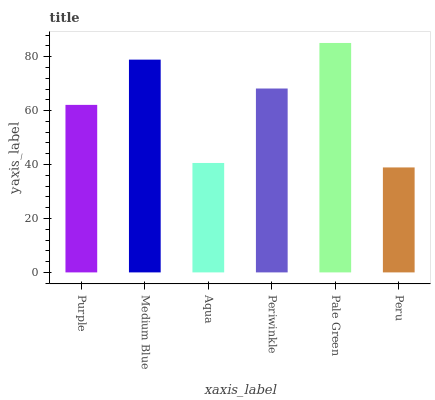Is Peru the minimum?
Answer yes or no. Yes. Is Pale Green the maximum?
Answer yes or no. Yes. Is Medium Blue the minimum?
Answer yes or no. No. Is Medium Blue the maximum?
Answer yes or no. No. Is Medium Blue greater than Purple?
Answer yes or no. Yes. Is Purple less than Medium Blue?
Answer yes or no. Yes. Is Purple greater than Medium Blue?
Answer yes or no. No. Is Medium Blue less than Purple?
Answer yes or no. No. Is Periwinkle the high median?
Answer yes or no. Yes. Is Purple the low median?
Answer yes or no. Yes. Is Pale Green the high median?
Answer yes or no. No. Is Medium Blue the low median?
Answer yes or no. No. 